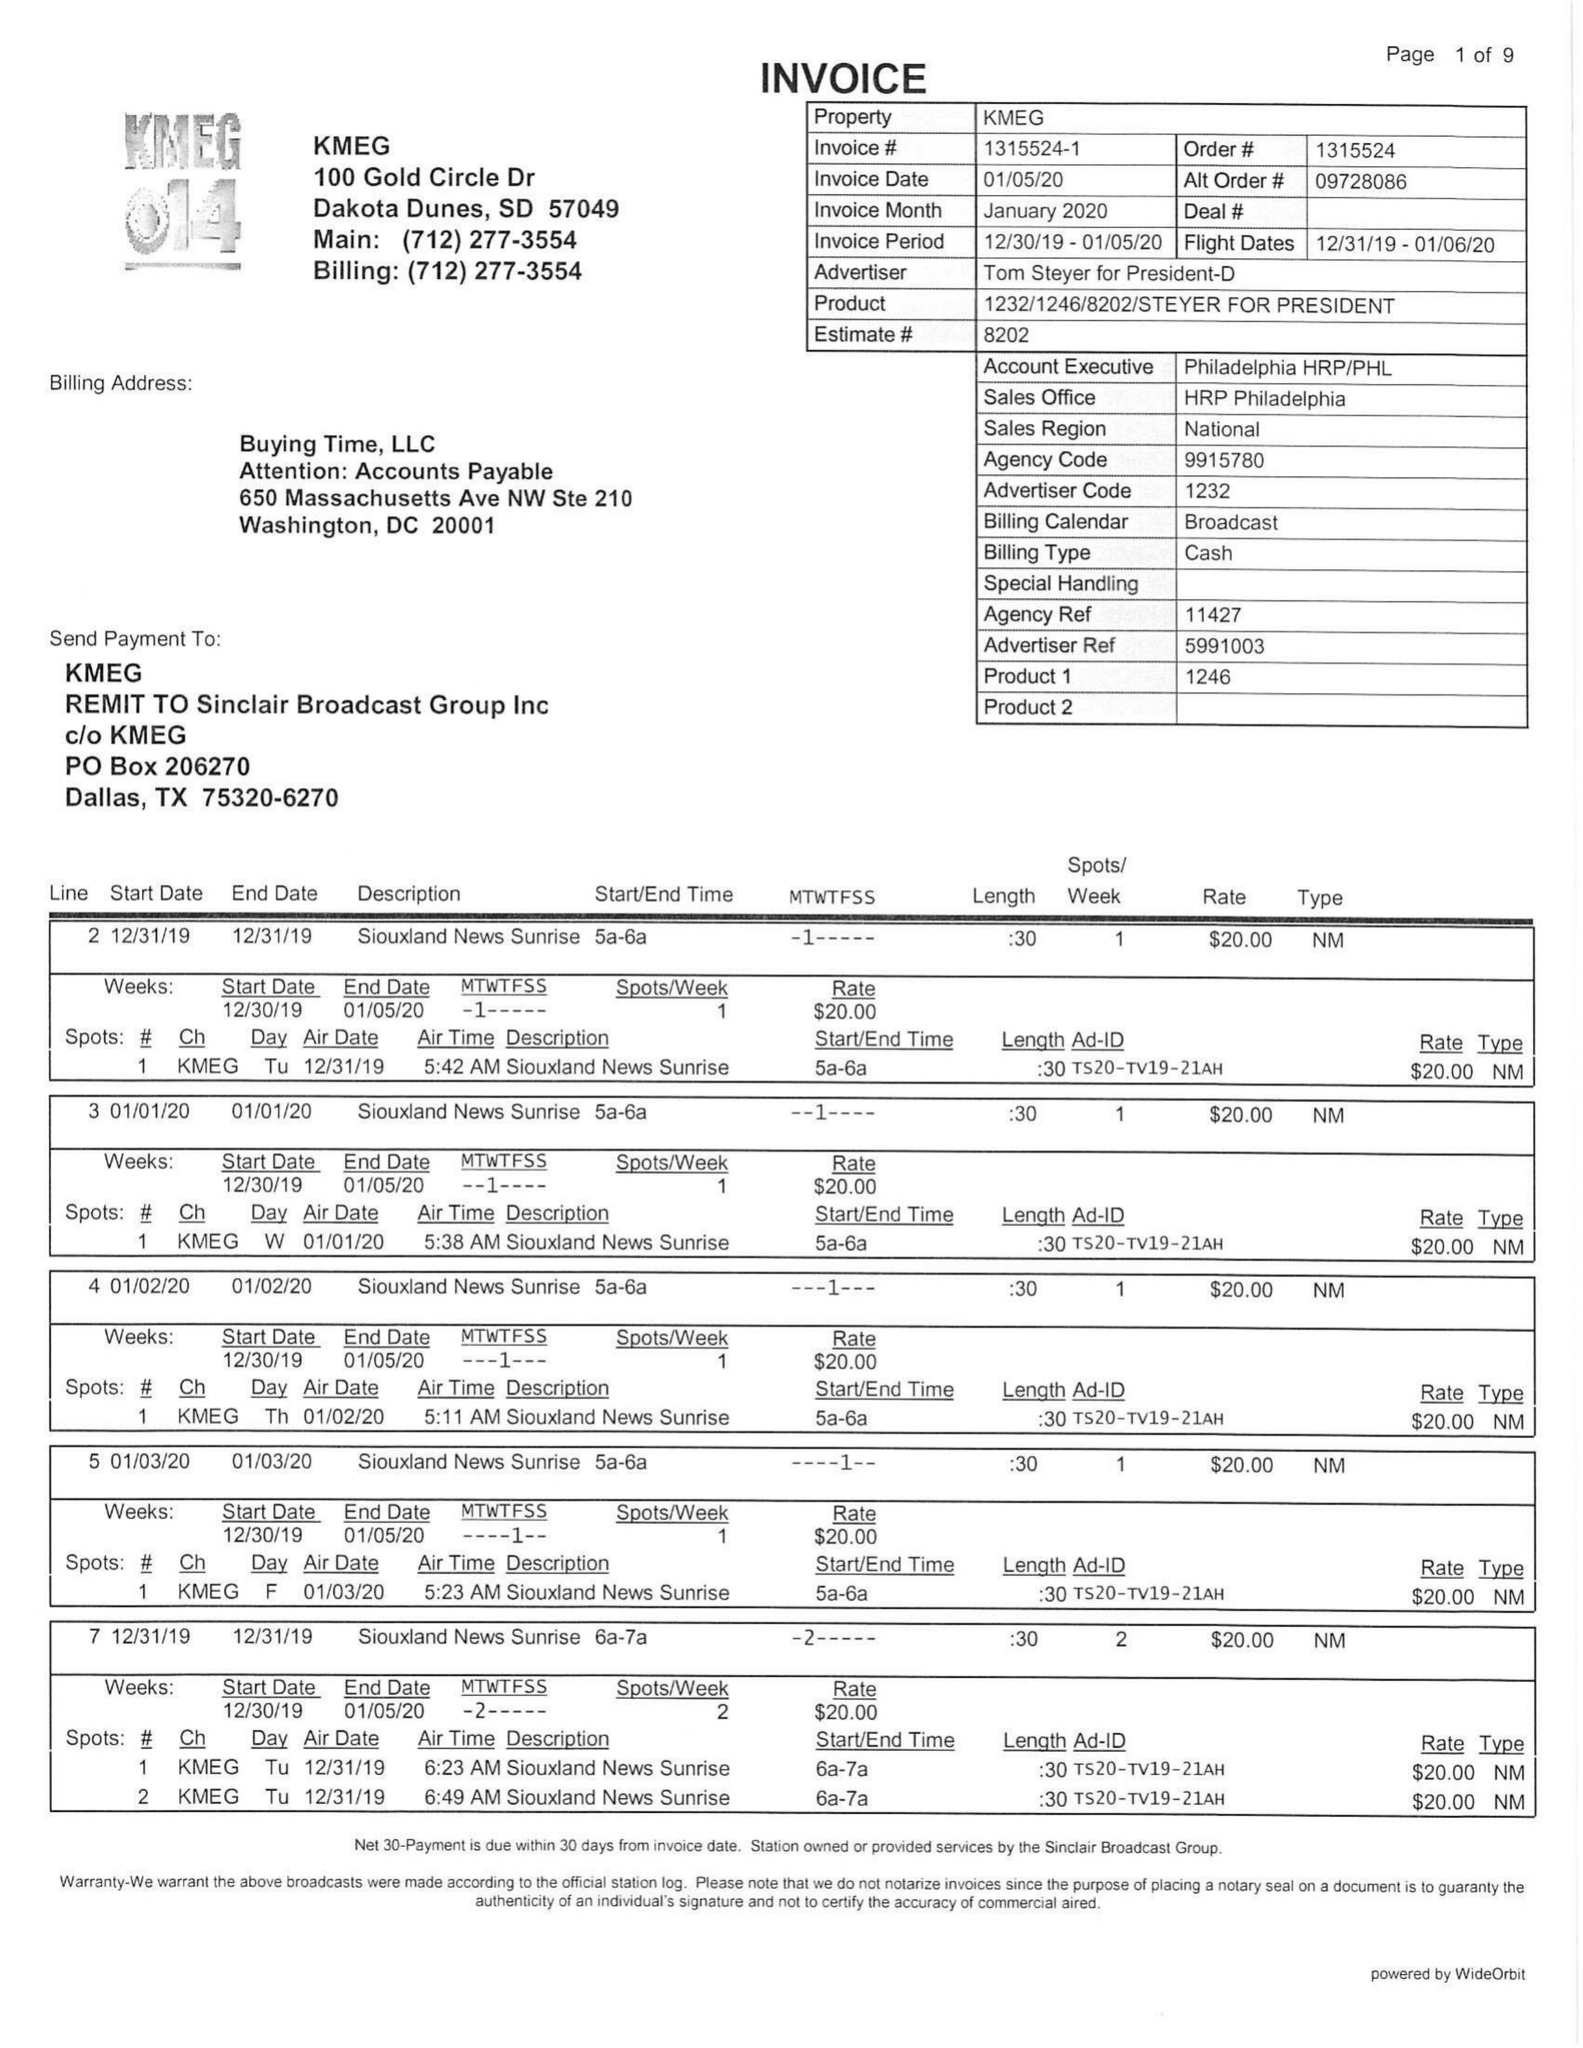What is the value for the advertiser?
Answer the question using a single word or phrase. TOM STEYER FOR PRESIDENT-D 